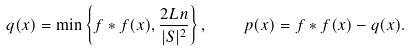Convert formula to latex. <formula><loc_0><loc_0><loc_500><loc_500>q ( x ) = \min \left \{ f * f ( x ) , \frac { 2 L n } { | S | ^ { 2 } } \right \} , \quad p ( x ) = f * f ( x ) - q ( x ) .</formula> 